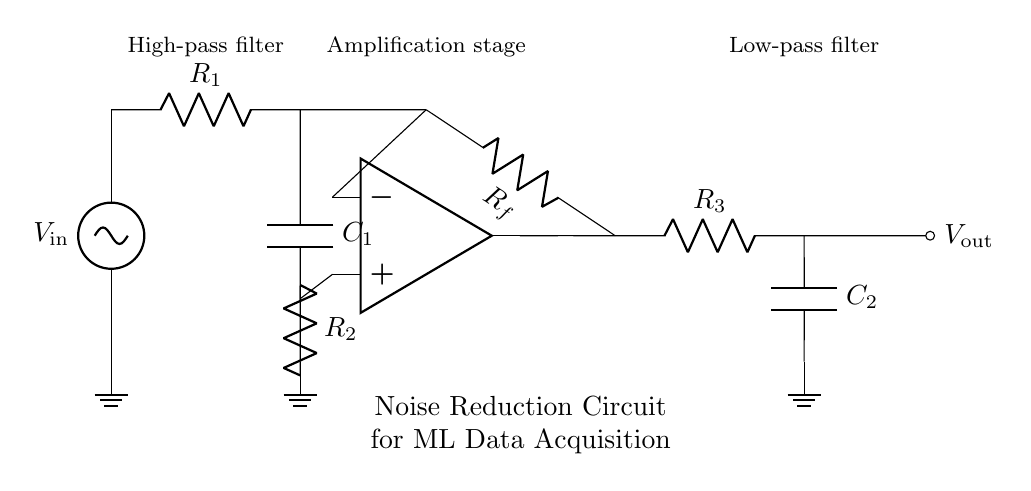What components are used in the high-pass filter? The high-pass filter consists of a resistor labeled R1 and a capacitor labeled C1 connected in series. The resistor allows high-frequency signals to pass while blocking lower frequencies, which is essential for noise reduction.
Answer: R1, C1 What is the function of the operational amplifier in this circuit? The operational amplifier amplifies the input signal after it passes through the high-pass filter. It uses feedback from resistor Rf, which helps to set the gain and stabilize the output signal. This is crucial for enhancing the quality of the acquired data.
Answer: Amplification What is the output from this noise reduction circuit? The output is taken from the low-pass filter, which smooths out high-frequency noise while allowing the desired signal to pass through. It ensures that the output signal is cleaner and more suitable for machine learning data acquisition.
Answer: Vout How many resistors are present in the entire circuit? There are four resistors in total: R1 (in the high-pass filter), R2 (part of the operational amplifier feedback), Rf (the feedback network), and R3 (in the low-pass filter). Each one plays a vital role in controlling the signal flow and filtering out noise.
Answer: 4 Which section of this circuit deals with noise frequency reduction? The circuit has two filters: the high-pass filter removes low-frequency noise, while the low-pass filter removes high-frequency noise. Together, these filters help maintain the integrity of the signal by filtering out unwanted frequency components.
Answer: High-pass and low-pass filters What is the purpose of capacitors in this circuit? The capacitors C1 (in the high-pass filter) and C2 (in the low-pass filter) store and release electrical energy, playing a key role in frequency response. C1 allows high frequencies to pass while blocking low ones, and C2 does the opposite, smoothing out the output signal.
Answer: C1, C2 